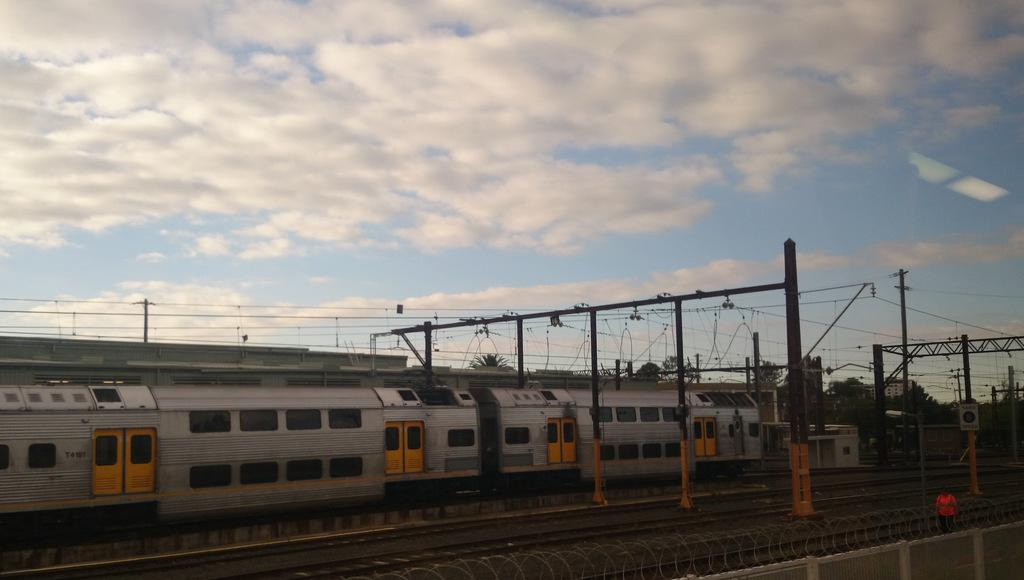What is the main subject of the image? The main subject of the image is a train. What is the train doing in the image? The train is moving on railway tracks. What can be seen beneath the train in the image? The railway tracks are visible in the image. What is visible at the top of the image? The sky is visible at the top of the image. Can you tell me how many snails are crawling on the ground in the image? There are no snails present in the image; it features a train moving on railway tracks. Who is the owner of the train in the image? There is no information provided about the ownership of the train in the image. 